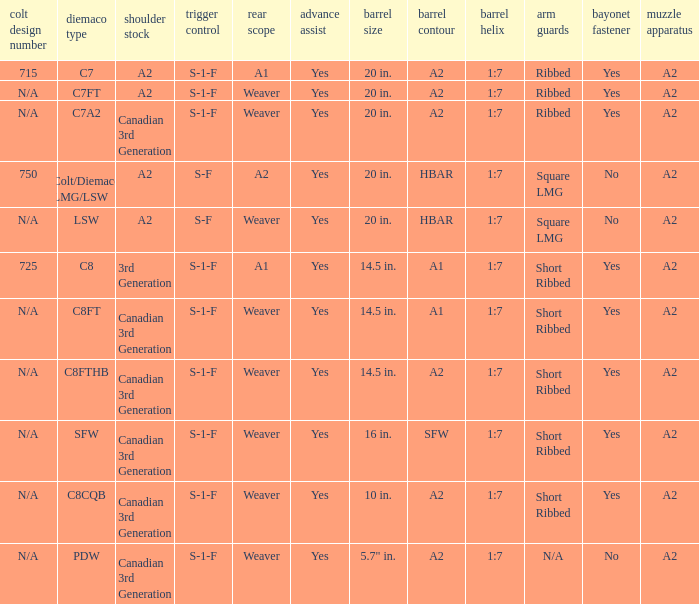Which hand shields feature an a2 barrel shape and a weaver-style rear sight? Ribbed, Ribbed, Short Ribbed, Short Ribbed, N/A. 